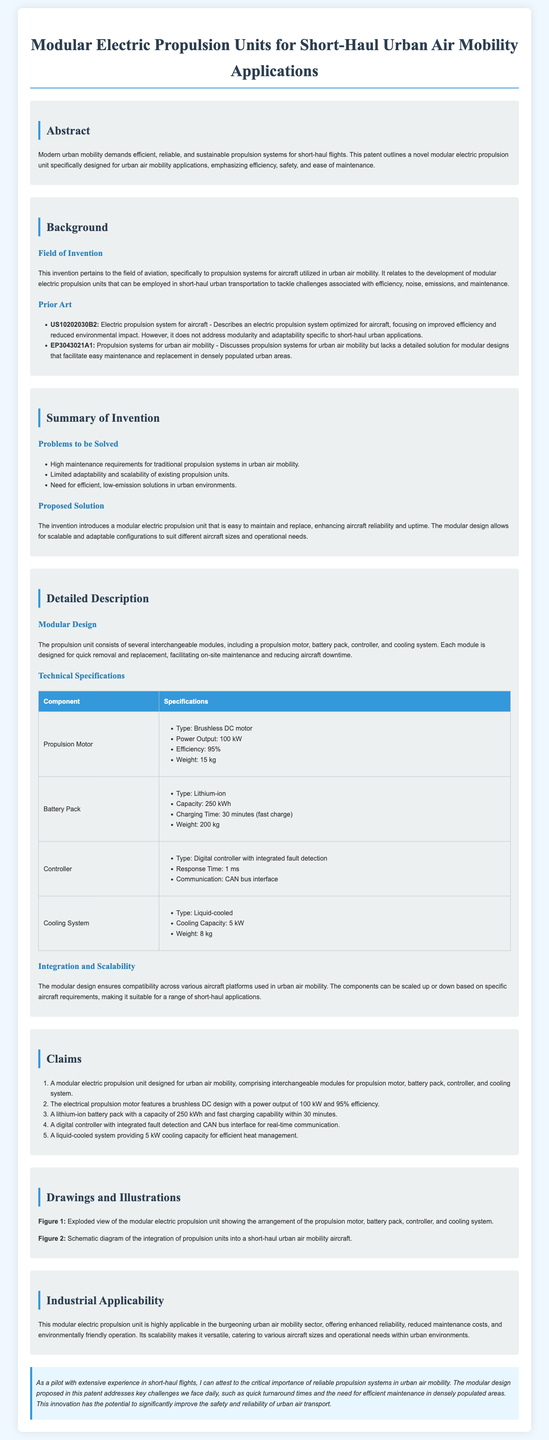What is the power output of the propulsion motor? The power output of the propulsion motor is specified in the technical specifications section as 100 kW.
Answer: 100 kW What type of battery is used in the propulsion unit? The type of battery used is mentioned in the technical specifications section, indicating it is a lithium-ion battery.
Answer: Lithium-ion How long does it take to fast charge the battery pack? The charging time for the battery pack is detailed in the technical specifications, which states it takes 30 minutes.
Answer: 30 minutes What are the main components of the modular electric propulsion unit? The components of the modular electric propulsion unit are outlined in the claims section, including a propulsion motor, battery pack, controller, and cooling system.
Answer: Propulsion motor, battery pack, controller, cooling system What is the efficiency of the propulsion motor? The efficiency of the propulsion motor is provided in the technical specifications section as 95%.
Answer: 95% Why is modularity important for urban air mobility propulsion systems? Modularity is emphasized in the summary section as a solution to high maintenance requirements and limited adaptability of existing systems; it enhances reliability and uptime.
Answer: Enhances reliability and uptime What figure shows the exploded view of the propulsion unit? The document references an exploded view in Figure 1, which illustrates the arrangement of the propulsion motor, battery pack, controller, and cooling system.
Answer: Figure 1 What is the cooling capacity of the cooling system? The cooling capacity of the cooling system is specified in the technical specifications section as 5 kW.
Answer: 5 kW What type of controller is mentioned for the propulsion unit? The type of controller described in the technical specifications is a digital controller with integrated fault detection.
Answer: Digital controller with integrated fault detection 